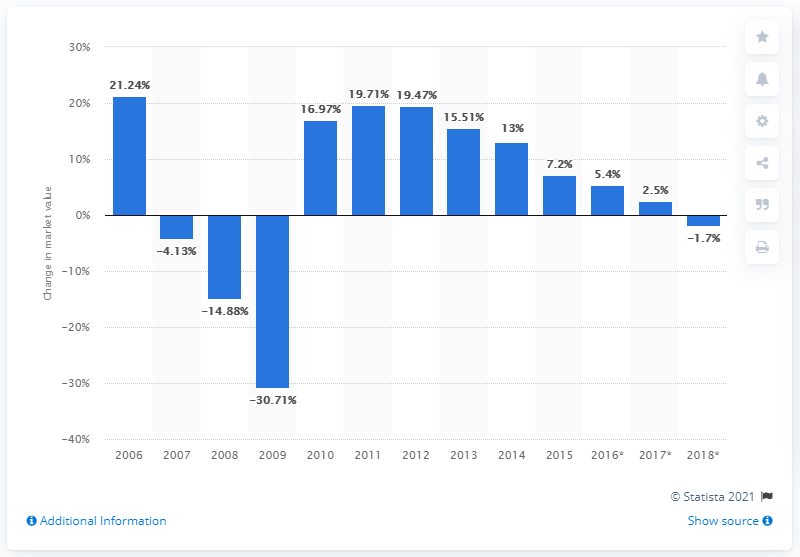Mention a couple of crucial points in this snapshot. The value of the hotel industry in the U.S. increased by 7.2% in 2015. In 2006, the U.S. hotel industry underwent a significant change in its market value. 